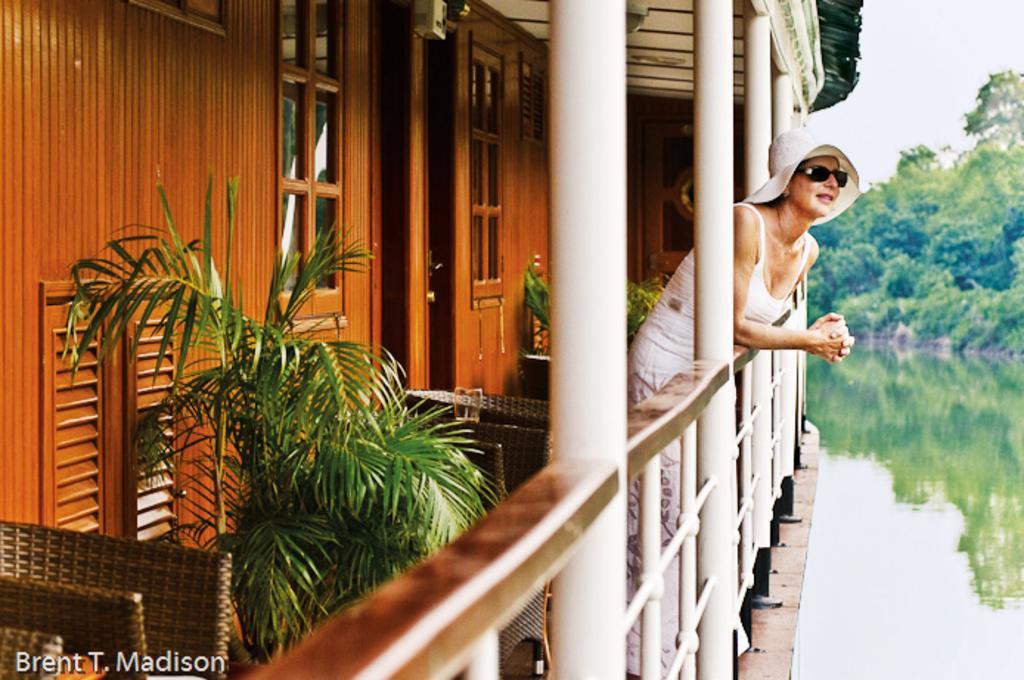Please provide a concise description of this image. There is a boat house and the woman is standing in the balcony of the boat house, behind her there is a door and two windows. The boat is on the water surface and in the background there are few trees. 